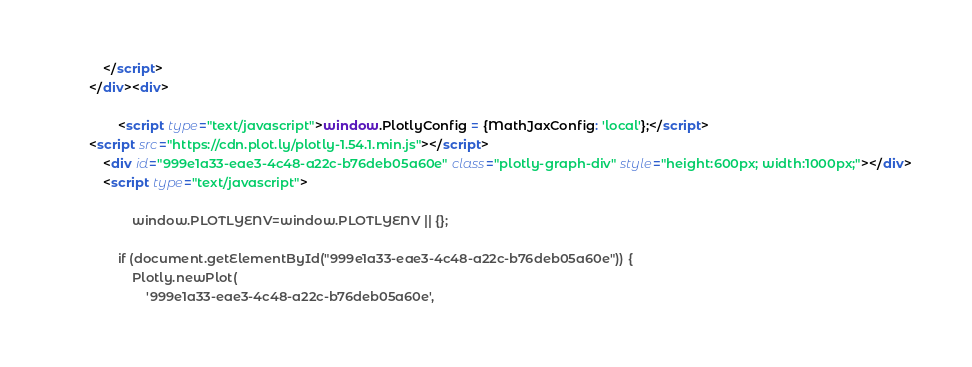Convert code to text. <code><loc_0><loc_0><loc_500><loc_500><_HTML_>            </script>
        </div><div>
        
                <script type="text/javascript">window.PlotlyConfig = {MathJaxConfig: 'local'};</script>
        <script src="https://cdn.plot.ly/plotly-1.54.1.min.js"></script>    
            <div id="999e1a33-eae3-4c48-a22c-b76deb05a60e" class="plotly-graph-div" style="height:600px; width:1000px;"></div>
            <script type="text/javascript">
                
                    window.PLOTLYENV=window.PLOTLYENV || {};
                    
                if (document.getElementById("999e1a33-eae3-4c48-a22c-b76deb05a60e")) {
                    Plotly.newPlot(
                        '999e1a33-eae3-4c48-a22c-b76deb05a60e',</code> 